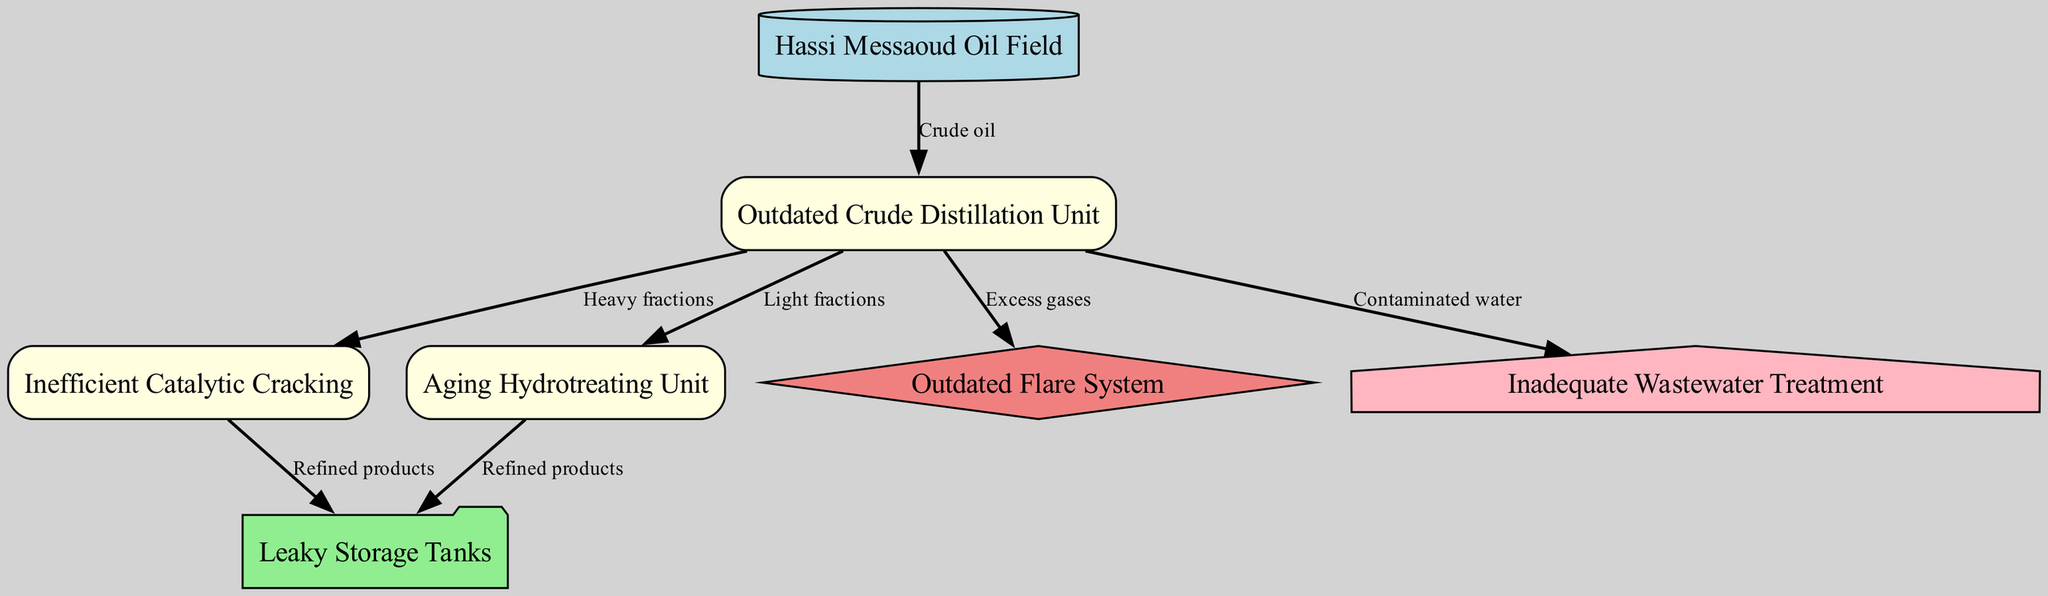What is the starting point of the process? The starting point is the "Hassi Messaoud Oil Field," which is indicated as the source node in the diagram. This node feeds crude oil into the process that follows.
Answer: Hassi Messaoud Oil Field How many processes are shown in the diagram? The diagram includes three process nodes: "Outdated Crude Distillation Unit," "Inefficient Catalytic Cracking," and "Aging Hydrotreating Unit." This total can be determined by counting the process nodes listed in the diagram.
Answer: 3 What is the end state of refined products in the diagram? The end state for refined products is the "Leaky Storage Tanks," which receive refined products from both the "Inefficient Catalytic Cracking" and "Aging Hydrotreating Unit" processes. This is evident from the connections depicted in the diagram.
Answer: Leaky Storage Tanks Which unit handles excess gases? The "Outdated Flare System" manages excess gases, as shown by the directed edge from the "Outdated Crude Distillation Unit" to the "Outdated Flare System." This connection indicates that excess gases are routed to this emission node.
Answer: Outdated Flare System What type of waste is produced from the "Outdated Crude Distillation Unit"? The "Outdated Crude Distillation Unit" produces "Contaminated water," indicated by a directed edge leading to the "Inadequate Wastewater Treatment" node that signifies waste output.
Answer: Contaminated water What relationships exist between "Inefficient Catalytic Cracking" and refined products? The "Inefficient Catalytic Cracking" unit is shown to produce refined products that are directed to "Leaky Storage Tanks," confirming a direct relationship between the two, as indicated by the edge in the diagram.
Answer: Refined products How many emissions are highlighted in the diagram? The diagram highlights one emission type: the "Outdated Flare System," which is the only emission node present. This can be verified by checking the nodes categorized under emissions in the diagram.
Answer: 1 What is the function of the "Aging Hydrotreating Unit"? The "Aging Hydrotreating Unit" processes light fractions from the "Outdated Crude Distillation Unit" and routes refined products to the "Leaky Storage Tanks," indicating its role in refining processes.
Answer: Refining light fractions 